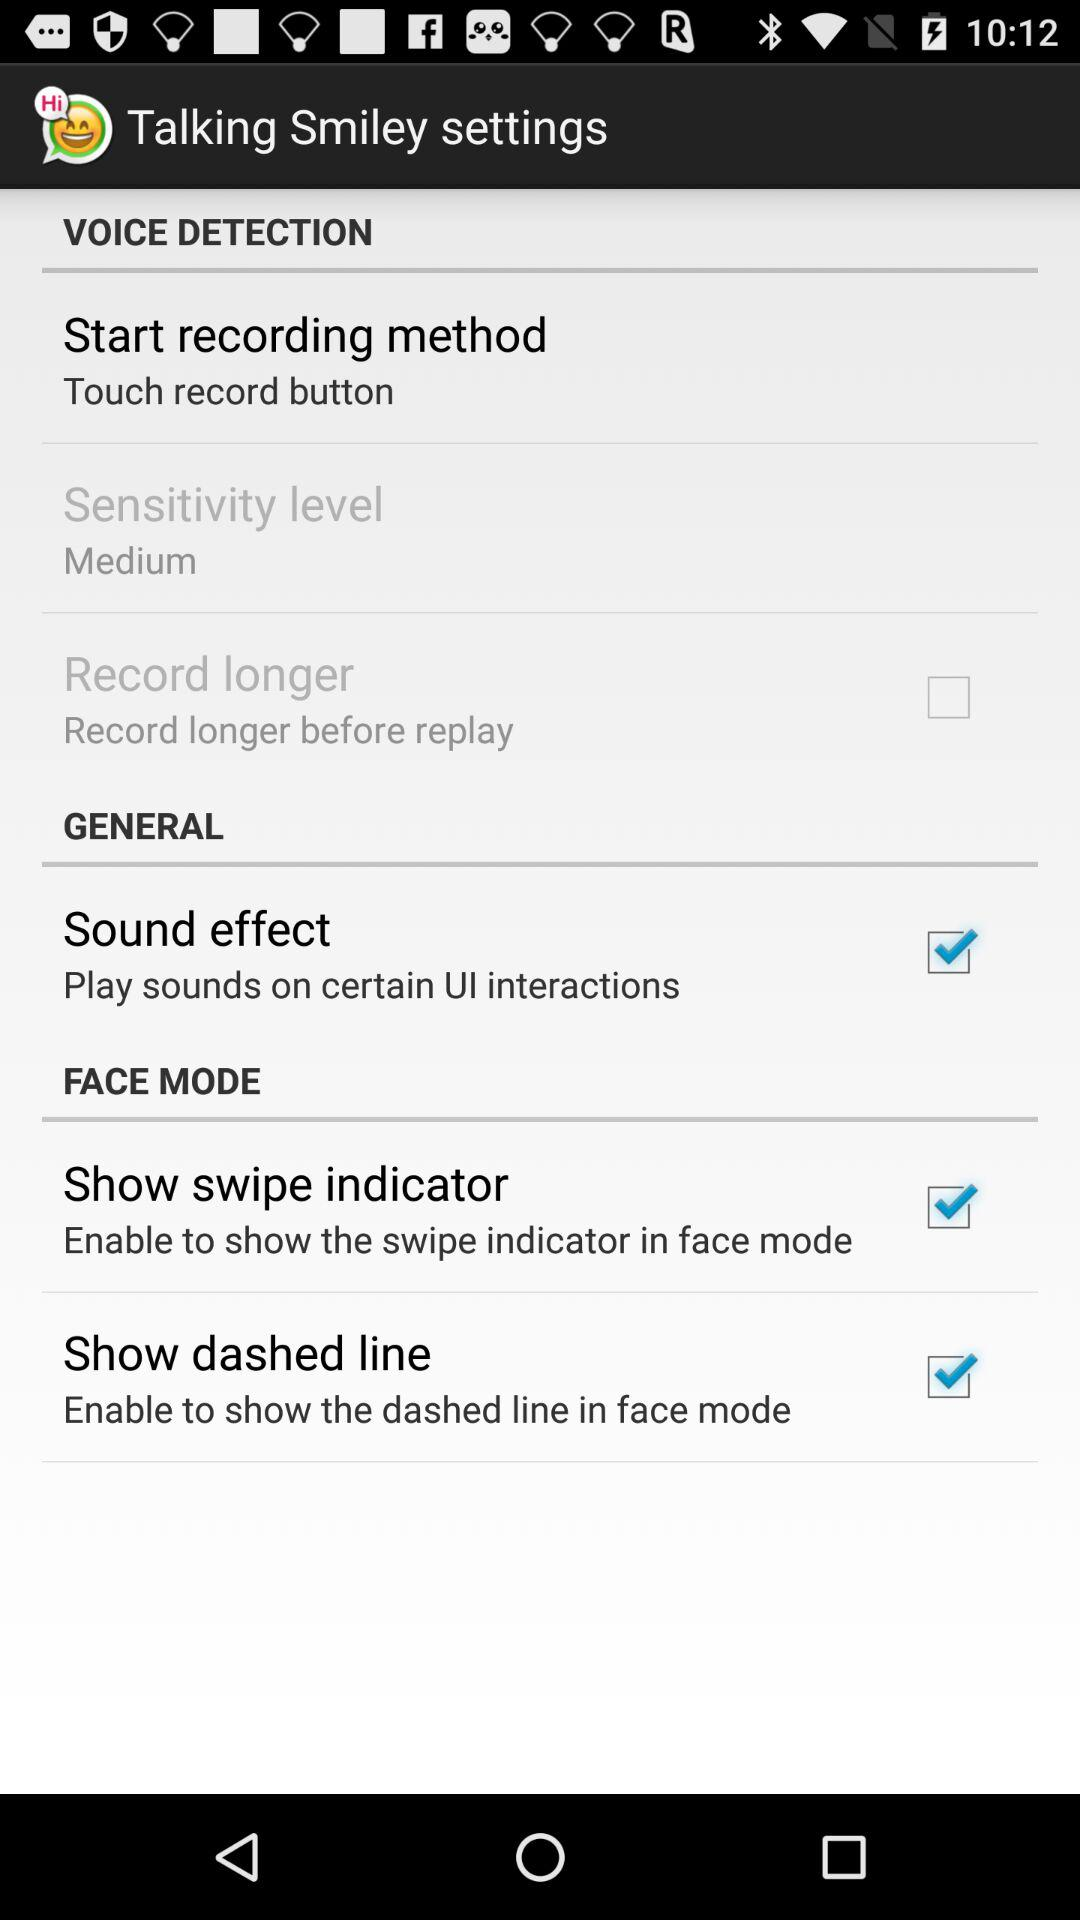What general settings are checked? The checked general setting is "Sound effect". 